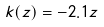<formula> <loc_0><loc_0><loc_500><loc_500>k ( z ) = - 2 . 1 z</formula> 